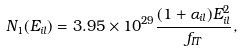Convert formula to latex. <formula><loc_0><loc_0><loc_500><loc_500>N _ { 1 } ( E _ { i l } ) = 3 . 9 5 \times 1 0 ^ { 2 9 } \frac { ( 1 + \alpha _ { i l } ) E _ { i l } ^ { 2 } } { f _ { I T } } ,</formula> 